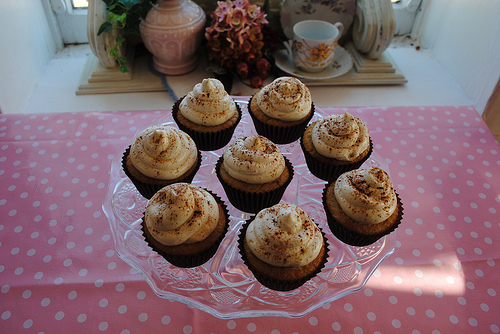<image>
Is the cup next to the cake? No. The cup is not positioned next to the cake. They are located in different areas of the scene. 